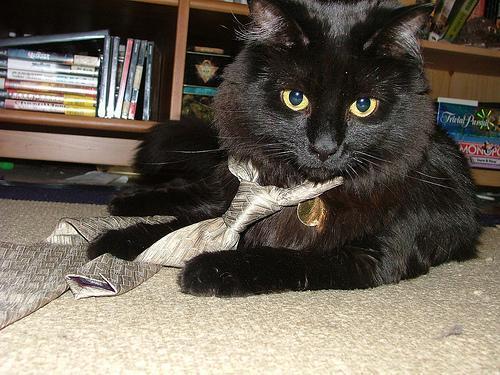How many ties are shown?
Give a very brief answer. 1. 